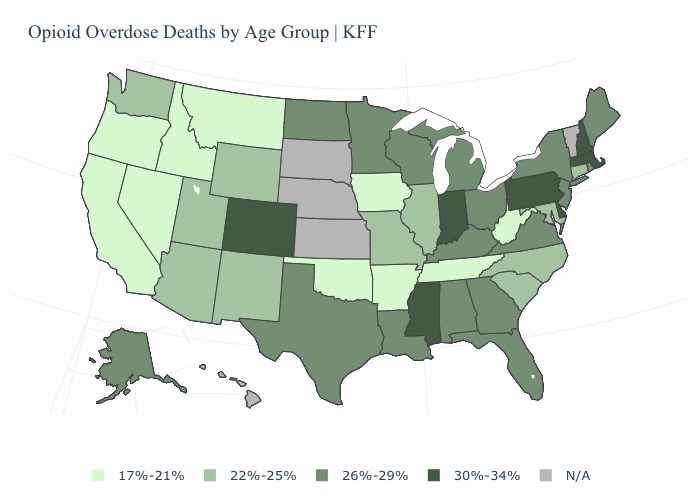Name the states that have a value in the range 22%-25%?
Concise answer only. Arizona, Connecticut, Illinois, Maryland, Missouri, New Mexico, North Carolina, South Carolina, Utah, Washington, Wyoming. Is the legend a continuous bar?
Keep it brief. No. Among the states that border Louisiana , which have the highest value?
Keep it brief. Mississippi. Name the states that have a value in the range 17%-21%?
Keep it brief. Arkansas, California, Idaho, Iowa, Montana, Nevada, Oklahoma, Oregon, Tennessee, West Virginia. How many symbols are there in the legend?
Keep it brief. 5. Does Iowa have the lowest value in the MidWest?
Give a very brief answer. Yes. What is the value of South Dakota?
Be succinct. N/A. What is the highest value in the Northeast ?
Be succinct. 30%-34%. Name the states that have a value in the range 17%-21%?
Give a very brief answer. Arkansas, California, Idaho, Iowa, Montana, Nevada, Oklahoma, Oregon, Tennessee, West Virginia. Name the states that have a value in the range 30%-34%?
Concise answer only. Colorado, Delaware, Indiana, Massachusetts, Mississippi, New Hampshire, Pennsylvania. Does the first symbol in the legend represent the smallest category?
Concise answer only. Yes. What is the lowest value in states that border Washington?
Short answer required. 17%-21%. Does California have the lowest value in the West?
Concise answer only. Yes. Name the states that have a value in the range 17%-21%?
Quick response, please. Arkansas, California, Idaho, Iowa, Montana, Nevada, Oklahoma, Oregon, Tennessee, West Virginia. Does Delaware have the highest value in the USA?
Give a very brief answer. Yes. 